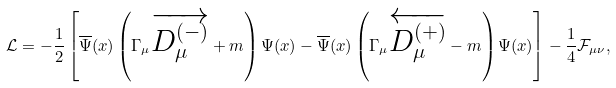<formula> <loc_0><loc_0><loc_500><loc_500>\mathcal { L } = - \frac { 1 } { 2 } \left [ \overline { \Psi } ( x ) \left ( \Gamma _ { \mu } \overrightarrow { D _ { \mu } ^ { ( - ) } } + m \right ) \Psi ( x ) - \overline { \Psi } ( x ) \left ( \Gamma _ { \mu } \overleftarrow { D _ { \mu } ^ { ( + ) } } - m \right ) \Psi ( x ) \right ] - \frac { 1 } { 4 } \mathcal { F } _ { \mu \nu } ,</formula> 